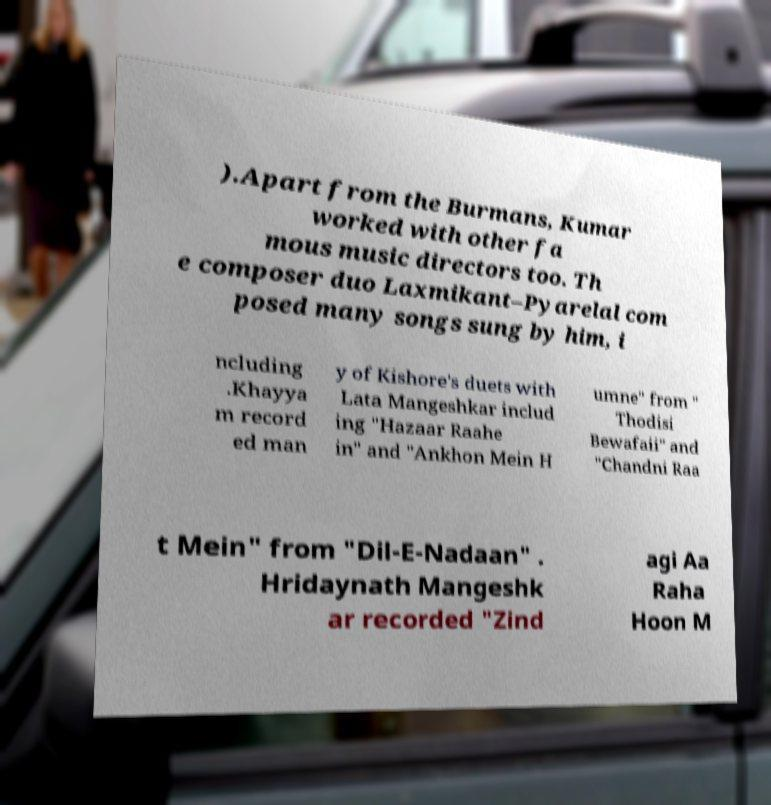Can you accurately transcribe the text from the provided image for me? ).Apart from the Burmans, Kumar worked with other fa mous music directors too. Th e composer duo Laxmikant–Pyarelal com posed many songs sung by him, i ncluding .Khayya m record ed man y of Kishore's duets with Lata Mangeshkar includ ing "Hazaar Raahe in" and "Ankhon Mein H umne" from " Thodisi Bewafaii" and "Chandni Raa t Mein" from "Dil-E-Nadaan" . Hridaynath Mangeshk ar recorded "Zind agi Aa Raha Hoon M 